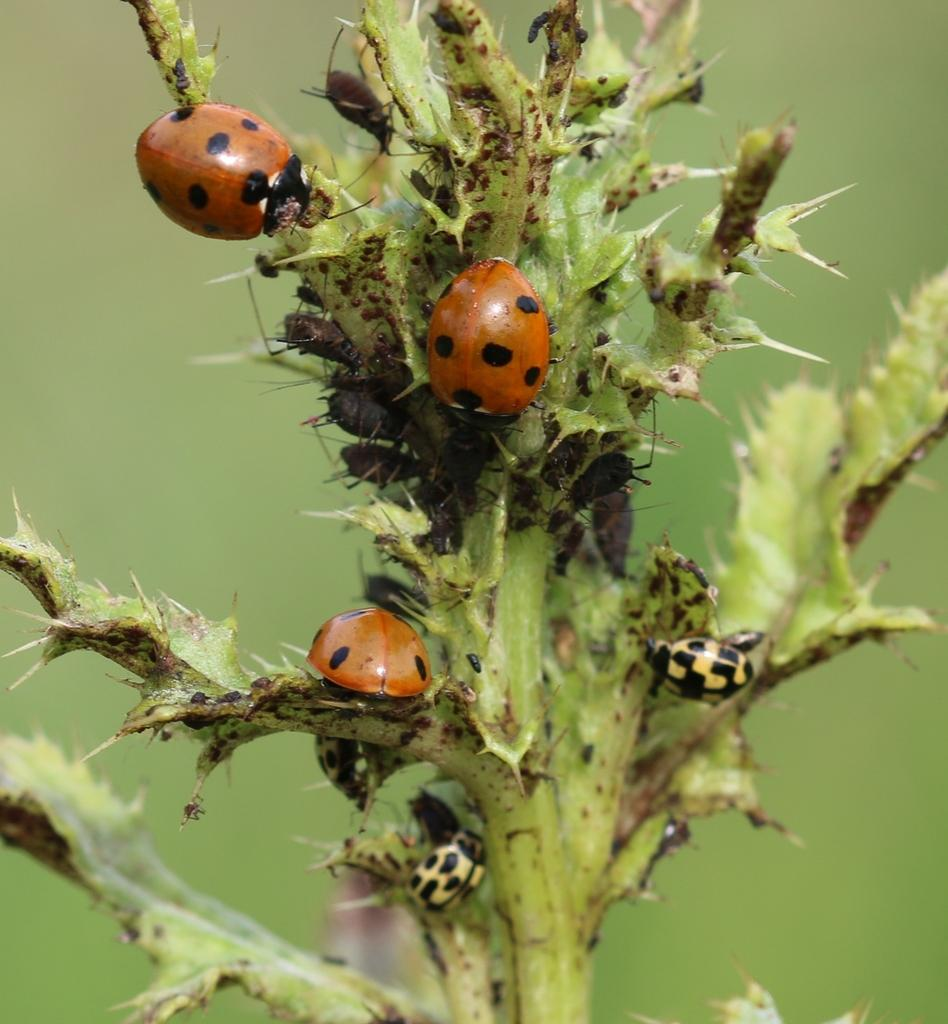What type of insects are on the cactus in the image? There are beetles on the cactus in the image. Can you describe the background of the image? The background of the image is blurred. What type of muscle can be seen flexing in the image? There is no muscle visible in the image; it features beetles on a cactus with a blurred background. 